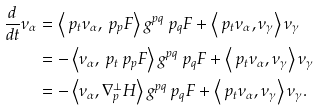Convert formula to latex. <formula><loc_0><loc_0><loc_500><loc_500>\frac { d } { d t } \nu _ { \alpha } & = \left \langle \ p _ { t } \nu _ { \alpha } , \ p _ { p } F \right \rangle g ^ { p q } \ p _ { q } F + \left \langle \ p _ { t } \nu _ { \alpha } , \nu _ { \gamma } \right \rangle \nu _ { \gamma } \\ & = - \left \langle \nu _ { \alpha } , \ p _ { t } \ p _ { p } F \right \rangle g ^ { p q } \ p _ { q } F + \left \langle \ p _ { t } \nu _ { \alpha } , \nu _ { \gamma } \right \rangle \nu _ { \gamma } \\ & = - \left \langle \nu _ { \alpha } , \nabla ^ { \bot } _ { p } H \right \rangle g ^ { p q } \ p _ { q } F + \left \langle \ p _ { t } \nu _ { \alpha } , \nu _ { \gamma } \right \rangle \nu _ { \gamma } .</formula> 